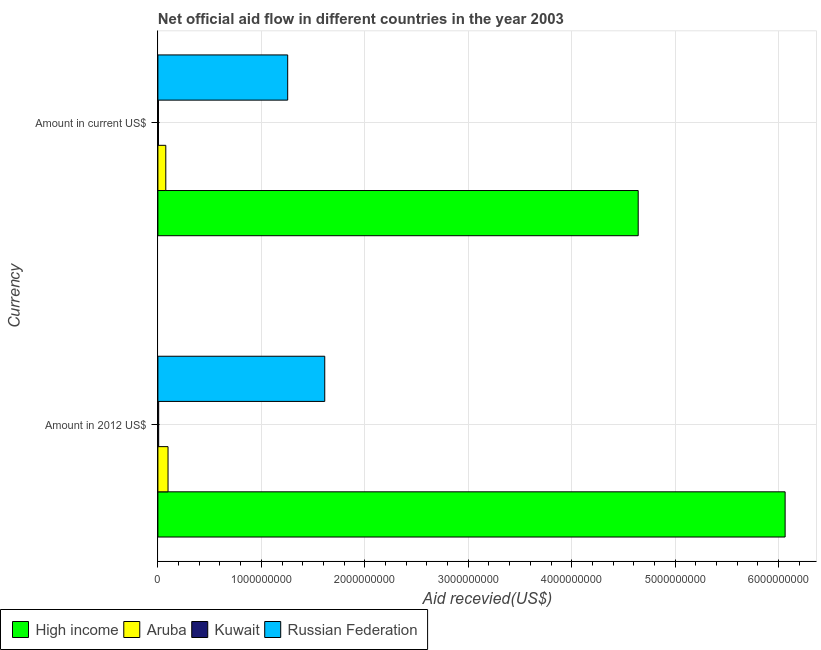How many different coloured bars are there?
Keep it short and to the point. 4. How many groups of bars are there?
Your answer should be compact. 2. Are the number of bars per tick equal to the number of legend labels?
Keep it short and to the point. Yes. How many bars are there on the 1st tick from the bottom?
Make the answer very short. 4. What is the label of the 1st group of bars from the top?
Provide a short and direct response. Amount in current US$. What is the amount of aid received(expressed in us$) in High income?
Your answer should be compact. 4.64e+09. Across all countries, what is the maximum amount of aid received(expressed in 2012 us$)?
Give a very brief answer. 6.06e+09. Across all countries, what is the minimum amount of aid received(expressed in us$)?
Offer a very short reply. 5.52e+06. In which country was the amount of aid received(expressed in 2012 us$) maximum?
Offer a terse response. High income. In which country was the amount of aid received(expressed in 2012 us$) minimum?
Make the answer very short. Kuwait. What is the total amount of aid received(expressed in us$) in the graph?
Offer a very short reply. 5.98e+09. What is the difference between the amount of aid received(expressed in us$) in Russian Federation and that in Aruba?
Offer a terse response. 1.18e+09. What is the difference between the amount of aid received(expressed in 2012 us$) in Kuwait and the amount of aid received(expressed in us$) in Aruba?
Your response must be concise. -6.89e+07. What is the average amount of aid received(expressed in 2012 us$) per country?
Offer a terse response. 1.95e+09. What is the difference between the amount of aid received(expressed in 2012 us$) and amount of aid received(expressed in us$) in Russian Federation?
Keep it short and to the point. 3.58e+08. What is the ratio of the amount of aid received(expressed in us$) in Kuwait to that in Russian Federation?
Provide a succinct answer. 0. What does the 2nd bar from the top in Amount in current US$ represents?
Make the answer very short. Kuwait. What does the 4th bar from the bottom in Amount in current US$ represents?
Give a very brief answer. Russian Federation. How many bars are there?
Offer a very short reply. 8. How are the legend labels stacked?
Offer a terse response. Horizontal. What is the title of the graph?
Provide a short and direct response. Net official aid flow in different countries in the year 2003. What is the label or title of the X-axis?
Offer a very short reply. Aid recevied(US$). What is the label or title of the Y-axis?
Offer a very short reply. Currency. What is the Aid recevied(US$) in High income in Amount in 2012 US$?
Provide a succinct answer. 6.06e+09. What is the Aid recevied(US$) in Aruba in Amount in 2012 US$?
Your response must be concise. 9.79e+07. What is the Aid recevied(US$) in Kuwait in Amount in 2012 US$?
Ensure brevity in your answer.  7.34e+06. What is the Aid recevied(US$) of Russian Federation in Amount in 2012 US$?
Offer a terse response. 1.61e+09. What is the Aid recevied(US$) of High income in Amount in current US$?
Your answer should be very brief. 4.64e+09. What is the Aid recevied(US$) in Aruba in Amount in current US$?
Your answer should be very brief. 7.62e+07. What is the Aid recevied(US$) of Kuwait in Amount in current US$?
Provide a short and direct response. 5.52e+06. What is the Aid recevied(US$) of Russian Federation in Amount in current US$?
Give a very brief answer. 1.25e+09. Across all Currency, what is the maximum Aid recevied(US$) in High income?
Ensure brevity in your answer.  6.06e+09. Across all Currency, what is the maximum Aid recevied(US$) in Aruba?
Provide a succinct answer. 9.79e+07. Across all Currency, what is the maximum Aid recevied(US$) of Kuwait?
Your response must be concise. 7.34e+06. Across all Currency, what is the maximum Aid recevied(US$) of Russian Federation?
Provide a short and direct response. 1.61e+09. Across all Currency, what is the minimum Aid recevied(US$) of High income?
Offer a very short reply. 4.64e+09. Across all Currency, what is the minimum Aid recevied(US$) in Aruba?
Your answer should be compact. 7.62e+07. Across all Currency, what is the minimum Aid recevied(US$) of Kuwait?
Offer a terse response. 5.52e+06. Across all Currency, what is the minimum Aid recevied(US$) of Russian Federation?
Make the answer very short. 1.25e+09. What is the total Aid recevied(US$) of High income in the graph?
Keep it short and to the point. 1.07e+1. What is the total Aid recevied(US$) in Aruba in the graph?
Provide a succinct answer. 1.74e+08. What is the total Aid recevied(US$) of Kuwait in the graph?
Your response must be concise. 1.29e+07. What is the total Aid recevied(US$) in Russian Federation in the graph?
Ensure brevity in your answer.  2.87e+09. What is the difference between the Aid recevied(US$) in High income in Amount in 2012 US$ and that in Amount in current US$?
Provide a short and direct response. 1.42e+09. What is the difference between the Aid recevied(US$) in Aruba in Amount in 2012 US$ and that in Amount in current US$?
Offer a terse response. 2.17e+07. What is the difference between the Aid recevied(US$) in Kuwait in Amount in 2012 US$ and that in Amount in current US$?
Your answer should be very brief. 1.82e+06. What is the difference between the Aid recevied(US$) of Russian Federation in Amount in 2012 US$ and that in Amount in current US$?
Your answer should be very brief. 3.58e+08. What is the difference between the Aid recevied(US$) of High income in Amount in 2012 US$ and the Aid recevied(US$) of Aruba in Amount in current US$?
Provide a succinct answer. 5.99e+09. What is the difference between the Aid recevied(US$) in High income in Amount in 2012 US$ and the Aid recevied(US$) in Kuwait in Amount in current US$?
Offer a terse response. 6.06e+09. What is the difference between the Aid recevied(US$) of High income in Amount in 2012 US$ and the Aid recevied(US$) of Russian Federation in Amount in current US$?
Give a very brief answer. 4.81e+09. What is the difference between the Aid recevied(US$) in Aruba in Amount in 2012 US$ and the Aid recevied(US$) in Kuwait in Amount in current US$?
Keep it short and to the point. 9.24e+07. What is the difference between the Aid recevied(US$) of Aruba in Amount in 2012 US$ and the Aid recevied(US$) of Russian Federation in Amount in current US$?
Your answer should be very brief. -1.16e+09. What is the difference between the Aid recevied(US$) of Kuwait in Amount in 2012 US$ and the Aid recevied(US$) of Russian Federation in Amount in current US$?
Make the answer very short. -1.25e+09. What is the average Aid recevied(US$) of High income per Currency?
Your answer should be compact. 5.35e+09. What is the average Aid recevied(US$) in Aruba per Currency?
Offer a terse response. 8.71e+07. What is the average Aid recevied(US$) of Kuwait per Currency?
Make the answer very short. 6.43e+06. What is the average Aid recevied(US$) of Russian Federation per Currency?
Your answer should be very brief. 1.43e+09. What is the difference between the Aid recevied(US$) of High income and Aid recevied(US$) of Aruba in Amount in 2012 US$?
Your answer should be compact. 5.96e+09. What is the difference between the Aid recevied(US$) of High income and Aid recevied(US$) of Kuwait in Amount in 2012 US$?
Offer a terse response. 6.06e+09. What is the difference between the Aid recevied(US$) of High income and Aid recevied(US$) of Russian Federation in Amount in 2012 US$?
Your response must be concise. 4.45e+09. What is the difference between the Aid recevied(US$) of Aruba and Aid recevied(US$) of Kuwait in Amount in 2012 US$?
Offer a very short reply. 9.06e+07. What is the difference between the Aid recevied(US$) of Aruba and Aid recevied(US$) of Russian Federation in Amount in 2012 US$?
Your response must be concise. -1.51e+09. What is the difference between the Aid recevied(US$) in Kuwait and Aid recevied(US$) in Russian Federation in Amount in 2012 US$?
Provide a succinct answer. -1.61e+09. What is the difference between the Aid recevied(US$) of High income and Aid recevied(US$) of Aruba in Amount in current US$?
Provide a short and direct response. 4.57e+09. What is the difference between the Aid recevied(US$) in High income and Aid recevied(US$) in Kuwait in Amount in current US$?
Make the answer very short. 4.64e+09. What is the difference between the Aid recevied(US$) of High income and Aid recevied(US$) of Russian Federation in Amount in current US$?
Your response must be concise. 3.39e+09. What is the difference between the Aid recevied(US$) of Aruba and Aid recevied(US$) of Kuwait in Amount in current US$?
Offer a terse response. 7.07e+07. What is the difference between the Aid recevied(US$) in Aruba and Aid recevied(US$) in Russian Federation in Amount in current US$?
Make the answer very short. -1.18e+09. What is the difference between the Aid recevied(US$) in Kuwait and Aid recevied(US$) in Russian Federation in Amount in current US$?
Ensure brevity in your answer.  -1.25e+09. What is the ratio of the Aid recevied(US$) in High income in Amount in 2012 US$ to that in Amount in current US$?
Keep it short and to the point. 1.31. What is the ratio of the Aid recevied(US$) in Aruba in Amount in 2012 US$ to that in Amount in current US$?
Make the answer very short. 1.28. What is the ratio of the Aid recevied(US$) in Kuwait in Amount in 2012 US$ to that in Amount in current US$?
Give a very brief answer. 1.33. What is the ratio of the Aid recevied(US$) of Russian Federation in Amount in 2012 US$ to that in Amount in current US$?
Provide a short and direct response. 1.29. What is the difference between the highest and the second highest Aid recevied(US$) in High income?
Give a very brief answer. 1.42e+09. What is the difference between the highest and the second highest Aid recevied(US$) of Aruba?
Provide a succinct answer. 2.17e+07. What is the difference between the highest and the second highest Aid recevied(US$) in Kuwait?
Your answer should be compact. 1.82e+06. What is the difference between the highest and the second highest Aid recevied(US$) of Russian Federation?
Ensure brevity in your answer.  3.58e+08. What is the difference between the highest and the lowest Aid recevied(US$) in High income?
Provide a succinct answer. 1.42e+09. What is the difference between the highest and the lowest Aid recevied(US$) of Aruba?
Your response must be concise. 2.17e+07. What is the difference between the highest and the lowest Aid recevied(US$) of Kuwait?
Your answer should be very brief. 1.82e+06. What is the difference between the highest and the lowest Aid recevied(US$) of Russian Federation?
Give a very brief answer. 3.58e+08. 